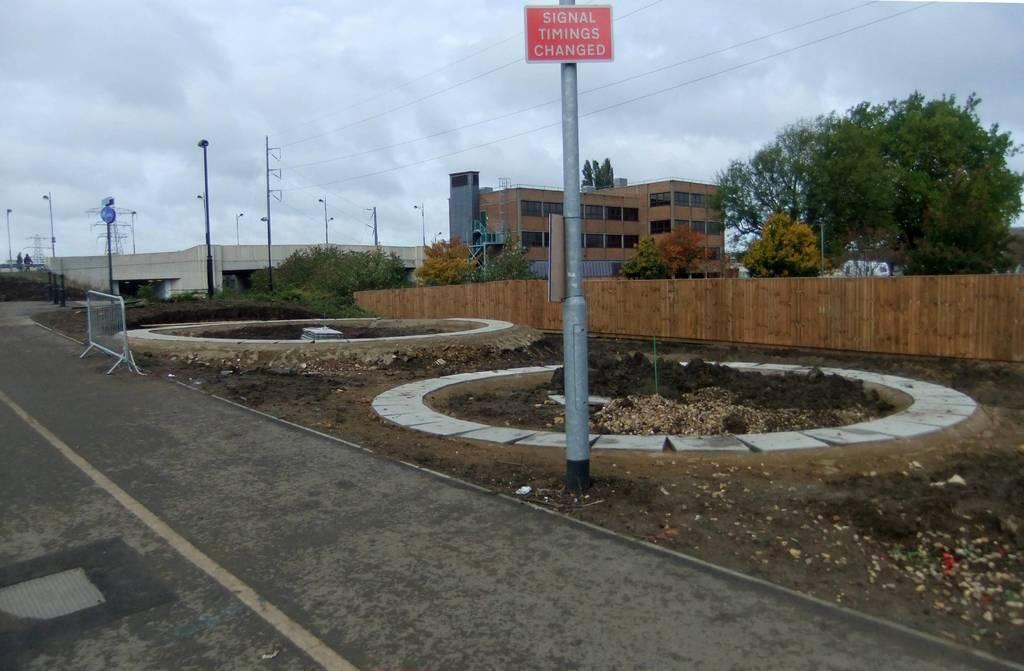Please provide a concise description of this image. In this image I can see the road, few metal poles, a red colored board attached to the pole, few wires, the railing, few trees which are orange, green and yellow in color, a bridge , few persons standing to the left side of the image and a building which is brown in color. In the background I can see the sky. 